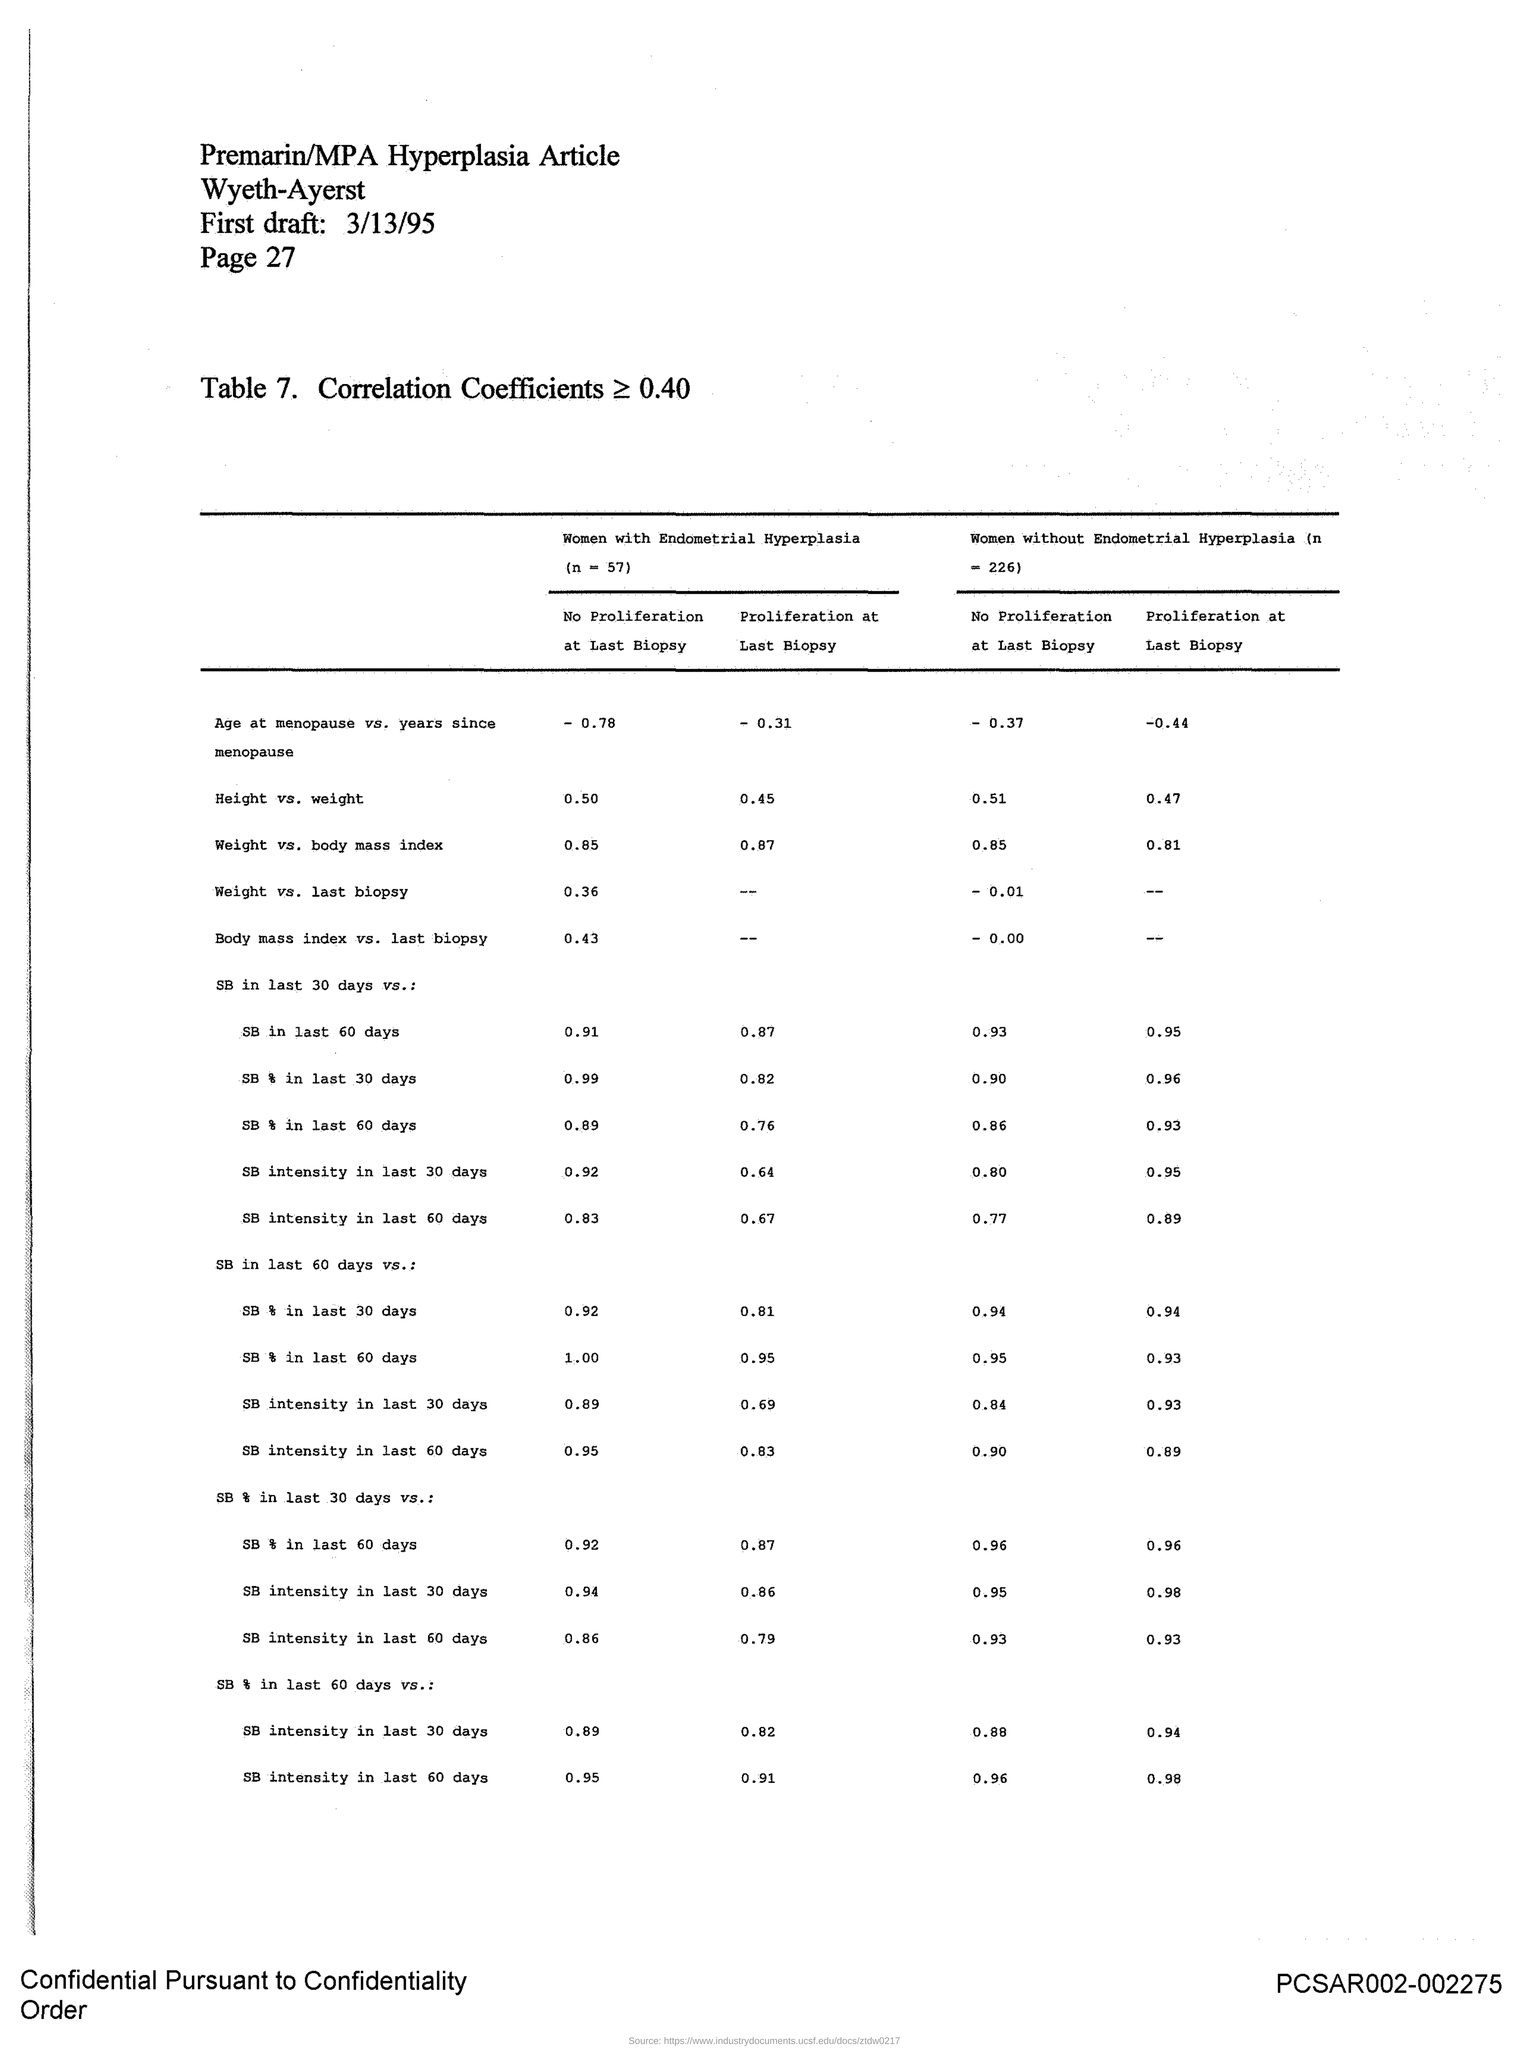What is the page no mentioned in this document?
Offer a very short reply. 27. What is the first draft date given in the document?
Your answer should be very brief. 3/13/95. 